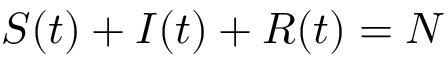<formula> <loc_0><loc_0><loc_500><loc_500>S ( t ) + I ( t ) + R ( t ) = N</formula> 